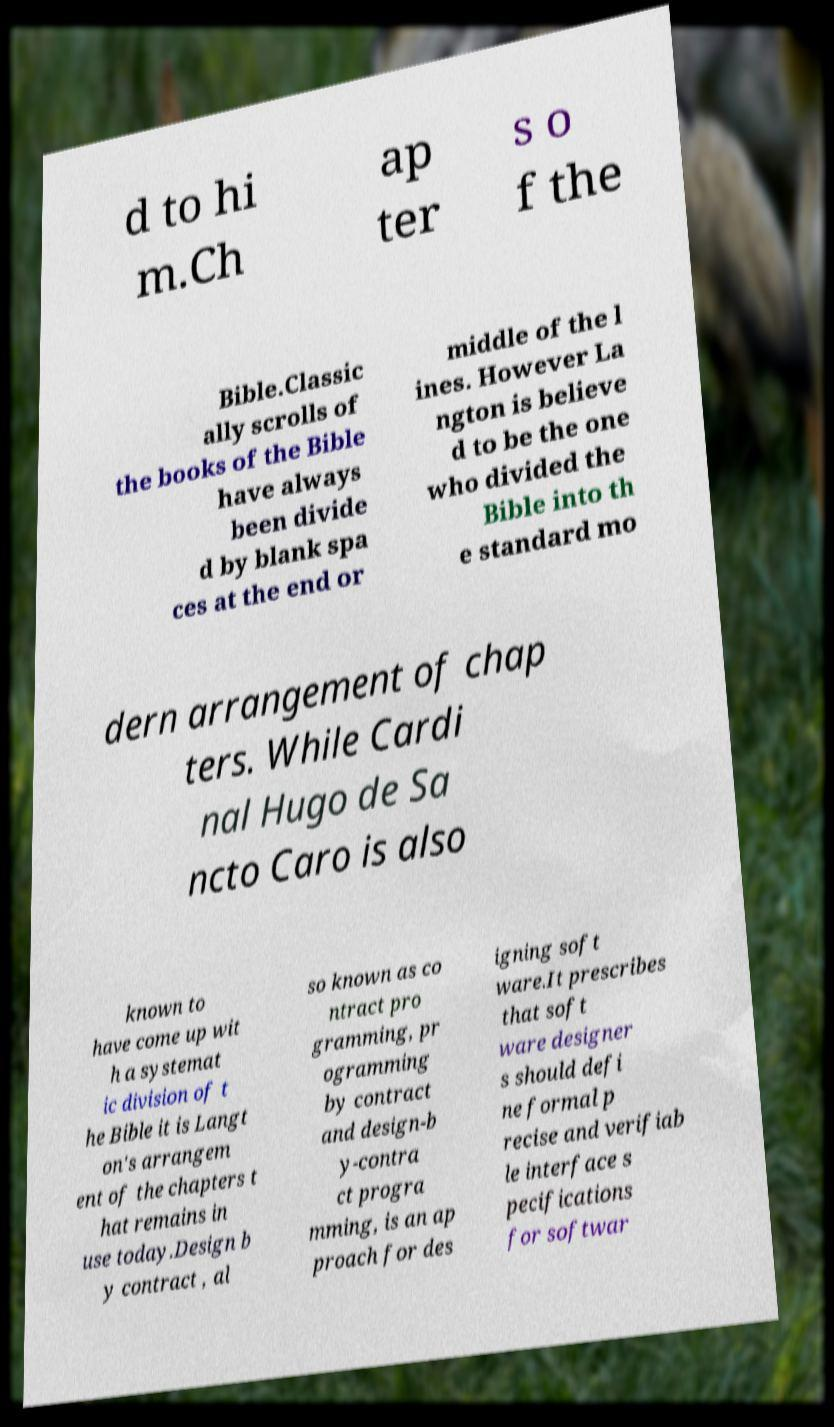I need the written content from this picture converted into text. Can you do that? d to hi m.Ch ap ter s o f the Bible.Classic ally scrolls of the books of the Bible have always been divide d by blank spa ces at the end or middle of the l ines. However La ngton is believe d to be the one who divided the Bible into th e standard mo dern arrangement of chap ters. While Cardi nal Hugo de Sa ncto Caro is also known to have come up wit h a systemat ic division of t he Bible it is Langt on's arrangem ent of the chapters t hat remains in use today.Design b y contract , al so known as co ntract pro gramming, pr ogramming by contract and design-b y-contra ct progra mming, is an ap proach for des igning soft ware.It prescribes that soft ware designer s should defi ne formal p recise and verifiab le interface s pecifications for softwar 